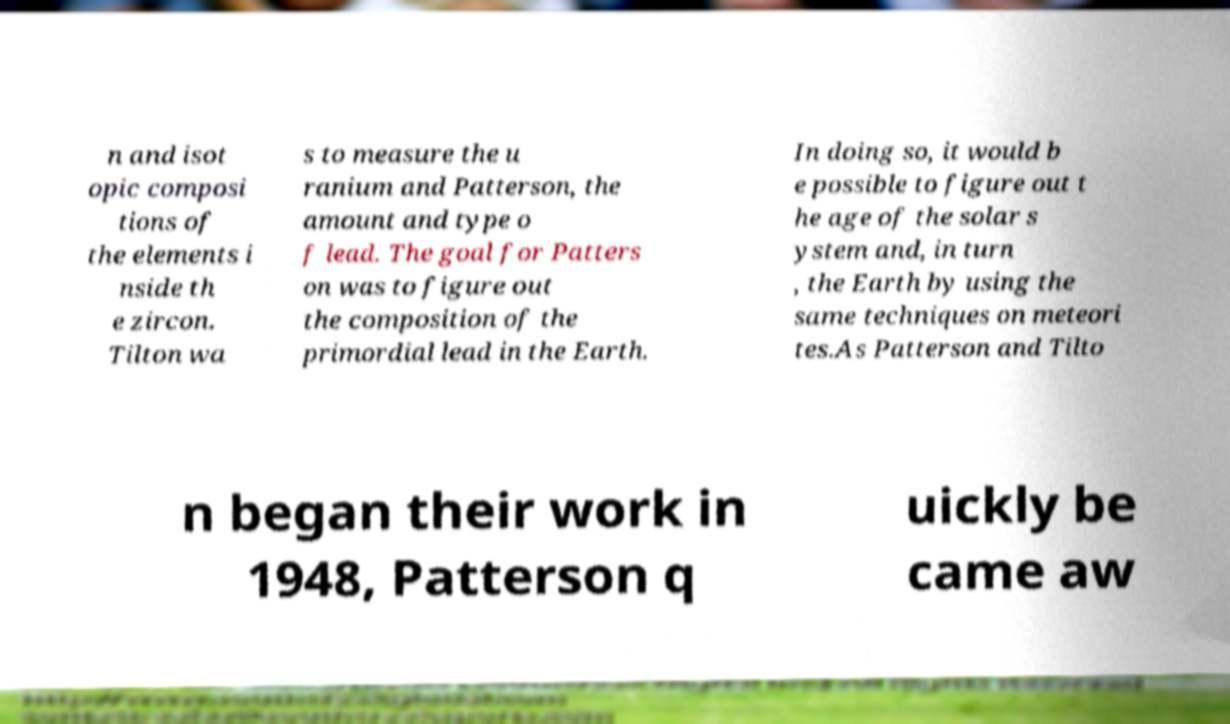Could you extract and type out the text from this image? n and isot opic composi tions of the elements i nside th e zircon. Tilton wa s to measure the u ranium and Patterson, the amount and type o f lead. The goal for Patters on was to figure out the composition of the primordial lead in the Earth. In doing so, it would b e possible to figure out t he age of the solar s ystem and, in turn , the Earth by using the same techniques on meteori tes.As Patterson and Tilto n began their work in 1948, Patterson q uickly be came aw 